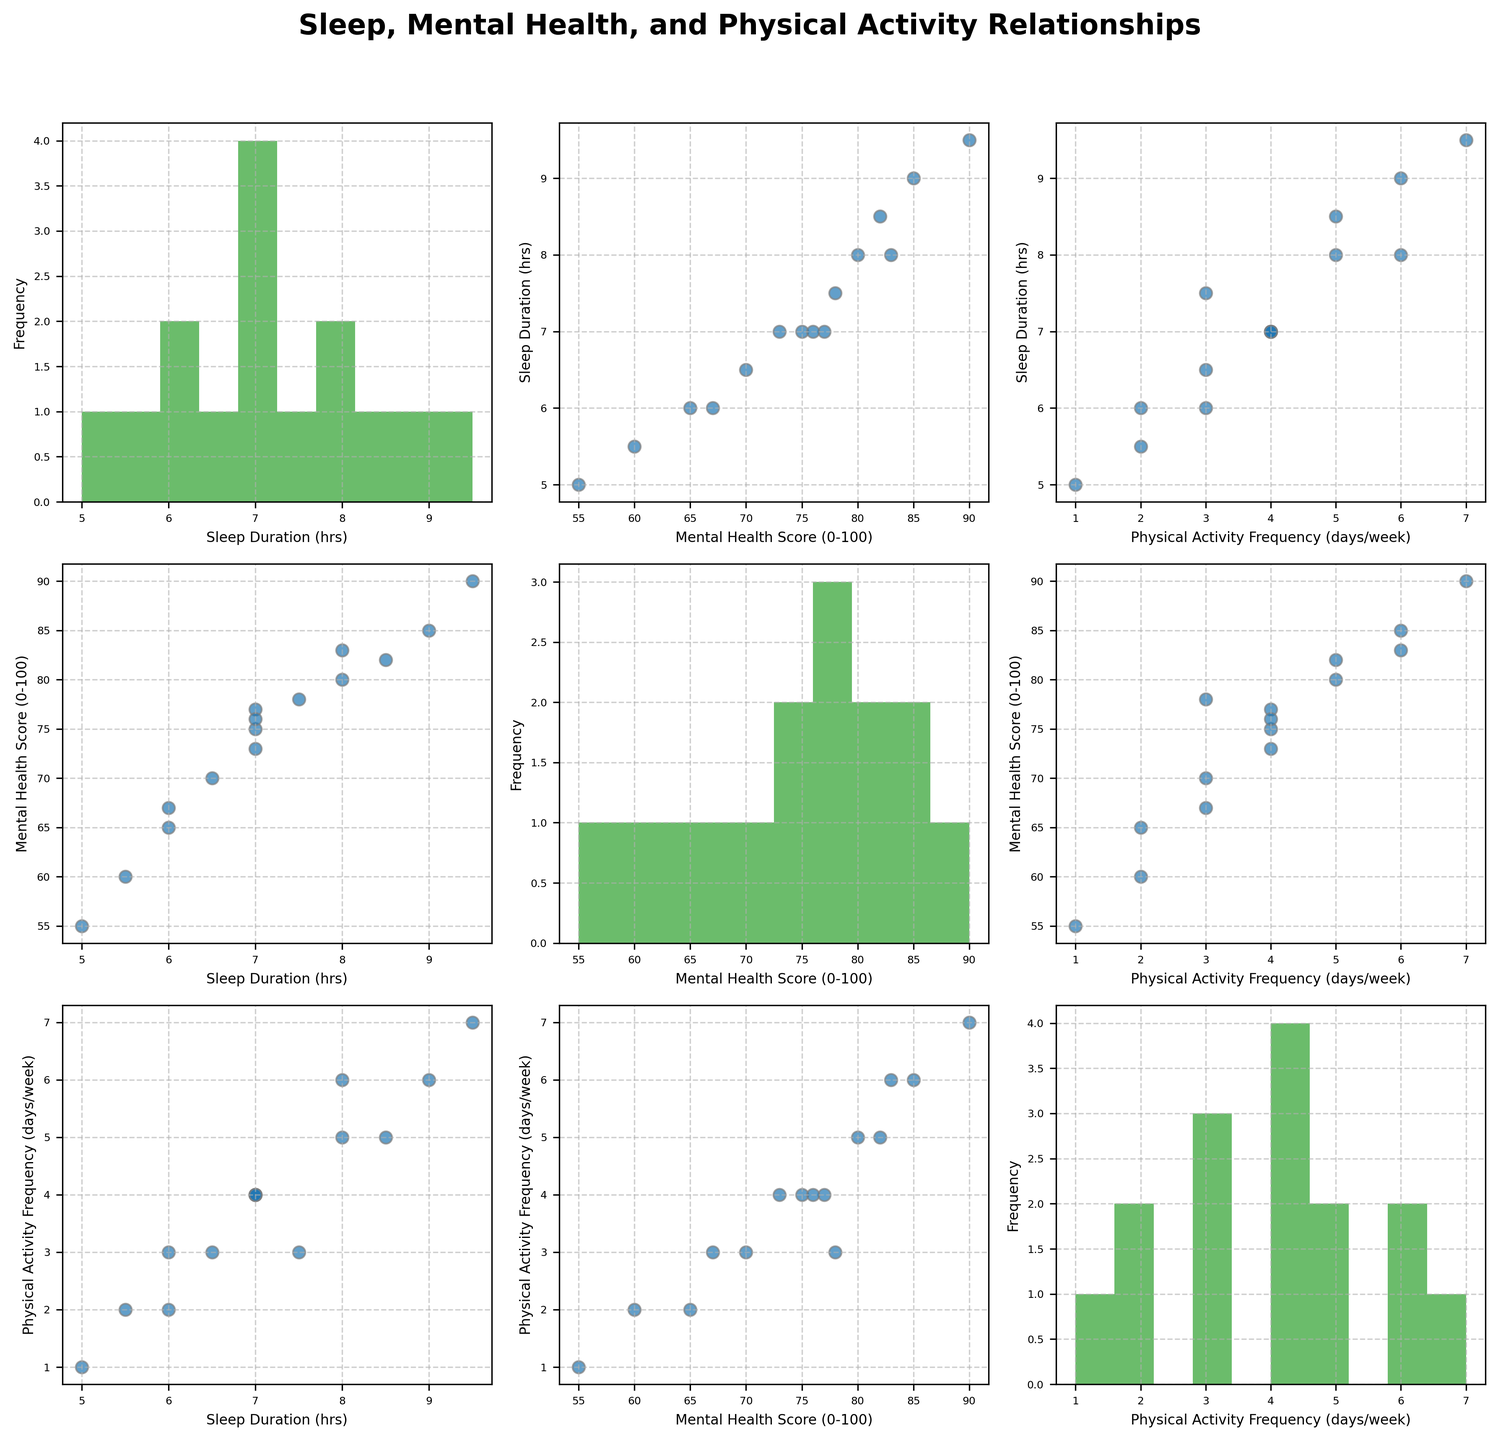How many data points are there for each variable? Each scatter plot and histogram in the figure shows 15 data points. This can be verified by counting the individual dots in any scatter plot or the number of entries in the histograms.
Answer: 15 Which variable has the highest range of values in its histogram? We can compare the histograms to see the range of values each variable spans. The Mental Health Score ranges from 55 to 90, which is the widest span compared to Sleep Duration (5 to 9.5) and Physical Activity Frequency (1 to 7).
Answer: Mental Health Score Is there a visible trend between Sleep Duration and Mental Health Score? By looking at the scatter plot of Sleep Duration vs. Mental Health Score, we notice a positive trend: as sleep duration increases, the mental health score seems to increase as well.
Answer: Positive trend Which two variables seem to have the strongest correlation? By visually comparing the scatter plots, the scatter plot of Mental Health Score vs. Physical Activity Frequency shows a clear positive trend, indicating a strong correlation between these two variables.
Answer: Mental Health Score and Physical Activity Frequency What is the average Physical Activity Frequency for participants with a Mental Health Score above 80? From the Mental Health Score vs. Physical Activity Frequency scatter plot, we identify points where the Mental Health Score is above 80. These correspond to Physical Activity Frequencies of 5, 6, and 7. The average is calculated as (5+6+7)/3.
Answer: 6 Which combination of variables results in the most concentrated cluster of data points? By observing the scatter plots, we see that the scatter plot of Sleep Duration vs. Mental Health Score has the most clustered group of points around the central range (Sleep Duration 6-8 hrs and Mental Health Score 70-80).
Answer: Sleep Duration and Mental Health Score For participants with 7 hours of Sleep Duration, what is their general range of Physical Activity Frequency? Cross-referencing Sleep Duration of 7 hours in the Sleep Duration vs. Physical Activity Frequency scatter plot shows that Physical Activity Frequency ranges between 2 and 4 days/week.
Answer: 2-4 days/week In the scatter plot of Sleep Duration vs Physical Activity Frequency, which Sleep Duration has the highest Physical Activity Frequency? By examining the scatter plot, we see that a Sleep Duration of 9.5 hours has the highest corresponding Physical Activity Frequency of 7 days/week.
Answer: 9.5 hours How does increasing Physical Activity Frequency affect the distribution of Mental Health Scores as seen in the scatter plots? The scatter plots indicate that as Physical Activity Frequency increases, Mental Health Scores generally increase, creating a spread in higher ranges of Mental Health Scores.
Answer: Higher Mental Health Scores with increased Physical Activity 